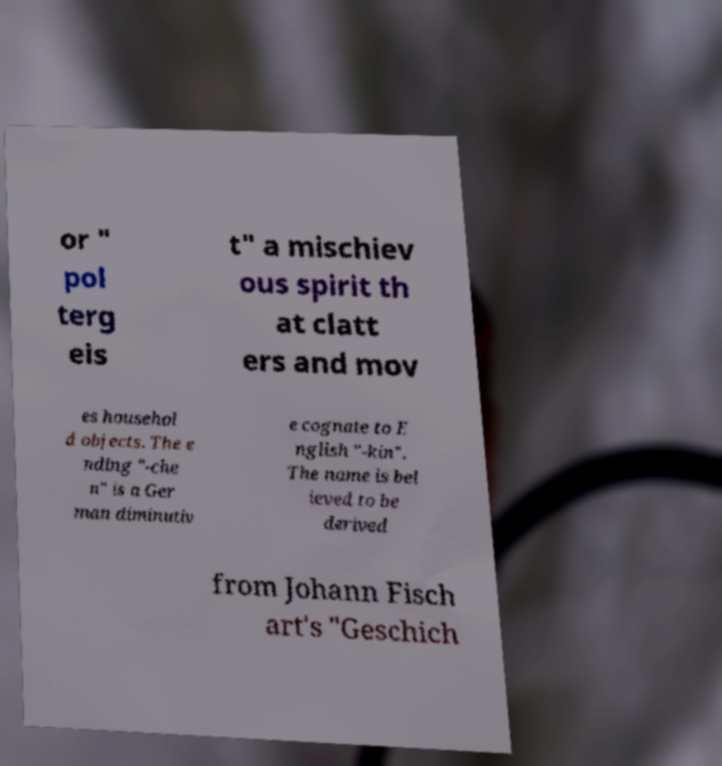What messages or text are displayed in this image? I need them in a readable, typed format. or " pol terg eis t" a mischiev ous spirit th at clatt ers and mov es househol d objects. The e nding "-che n" is a Ger man diminutiv e cognate to E nglish "-kin". The name is bel ieved to be derived from Johann Fisch art's "Geschich 